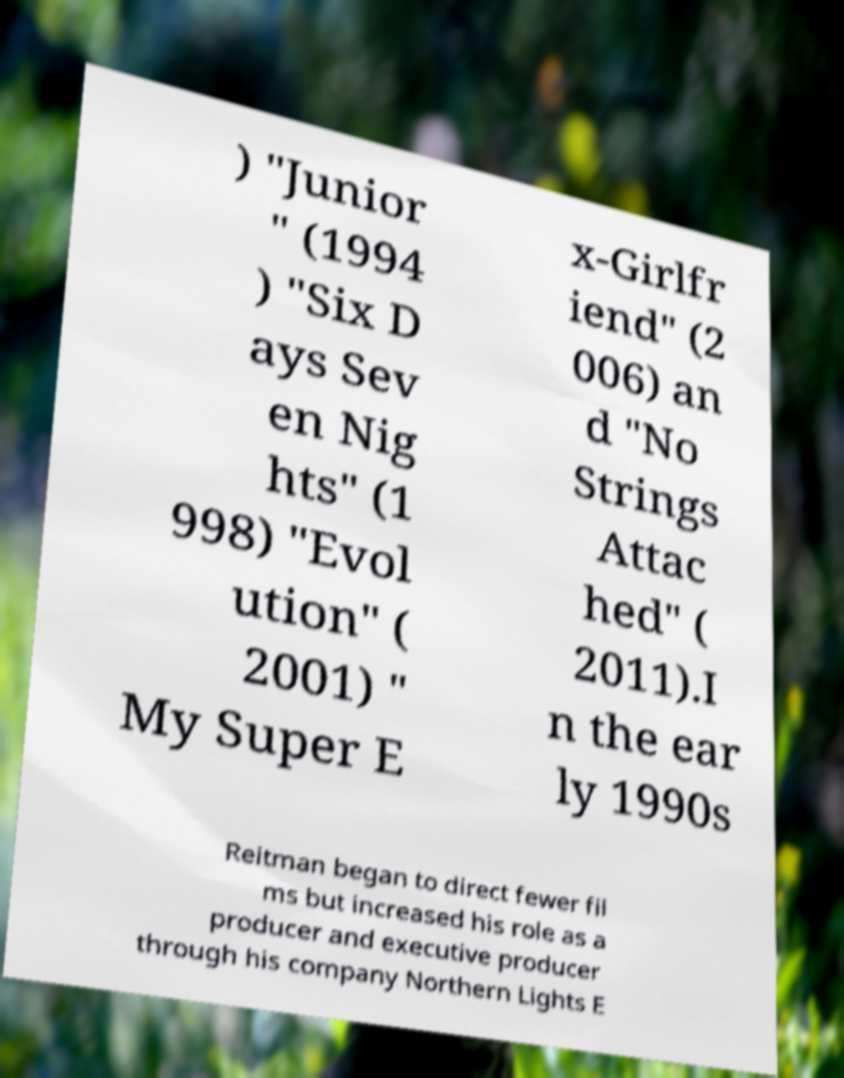Could you extract and type out the text from this image? ) "Junior " (1994 ) "Six D ays Sev en Nig hts" (1 998) "Evol ution" ( 2001) " My Super E x-Girlfr iend" (2 006) an d "No Strings Attac hed" ( 2011).I n the ear ly 1990s Reitman began to direct fewer fil ms but increased his role as a producer and executive producer through his company Northern Lights E 